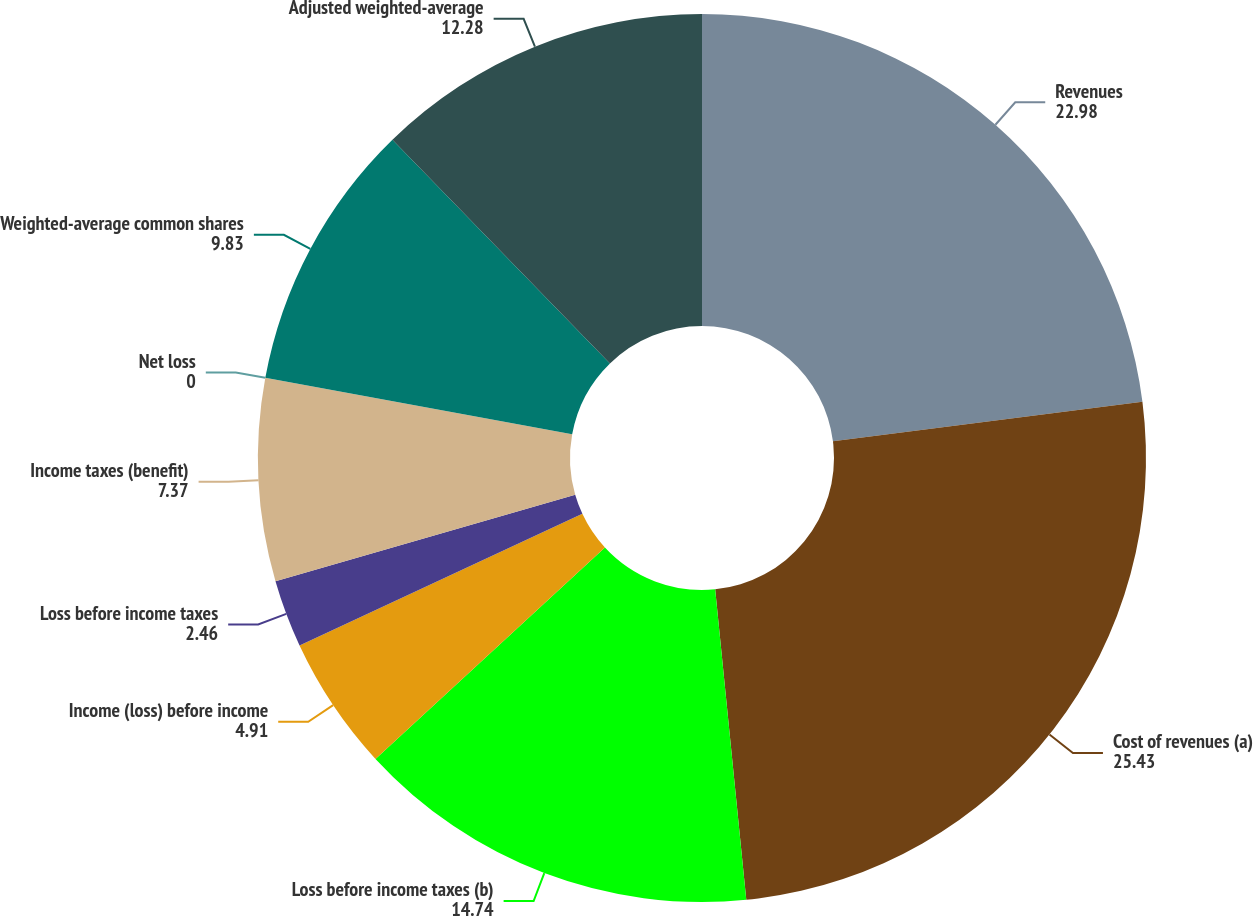Convert chart to OTSL. <chart><loc_0><loc_0><loc_500><loc_500><pie_chart><fcel>Revenues<fcel>Cost of revenues (a)<fcel>Loss before income taxes (b)<fcel>Income (loss) before income<fcel>Loss before income taxes<fcel>Income taxes (benefit)<fcel>Net loss<fcel>Weighted-average common shares<fcel>Adjusted weighted-average<nl><fcel>22.98%<fcel>25.43%<fcel>14.74%<fcel>4.91%<fcel>2.46%<fcel>7.37%<fcel>0.0%<fcel>9.83%<fcel>12.28%<nl></chart> 